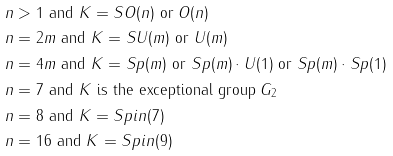Convert formula to latex. <formula><loc_0><loc_0><loc_500><loc_500>& n > 1 \text { and } K = S O ( n ) \text { or } O ( n ) \\ & n = 2 m \text { and } K = S U ( m ) \text { or } U ( m ) \\ & n = 4 m \text { and } K = S p ( m ) \text { or } S p ( m ) \cdot U ( 1 ) \text { or } S p ( m ) \cdot S p ( 1 ) \\ & n = 7 \text { and } K \text { is the exceptional group } G _ { 2 } \\ & n = 8 \text { and } K = S p i n ( 7 ) \\ & n = 1 6 \text { and } K = S p i n ( 9 )</formula> 